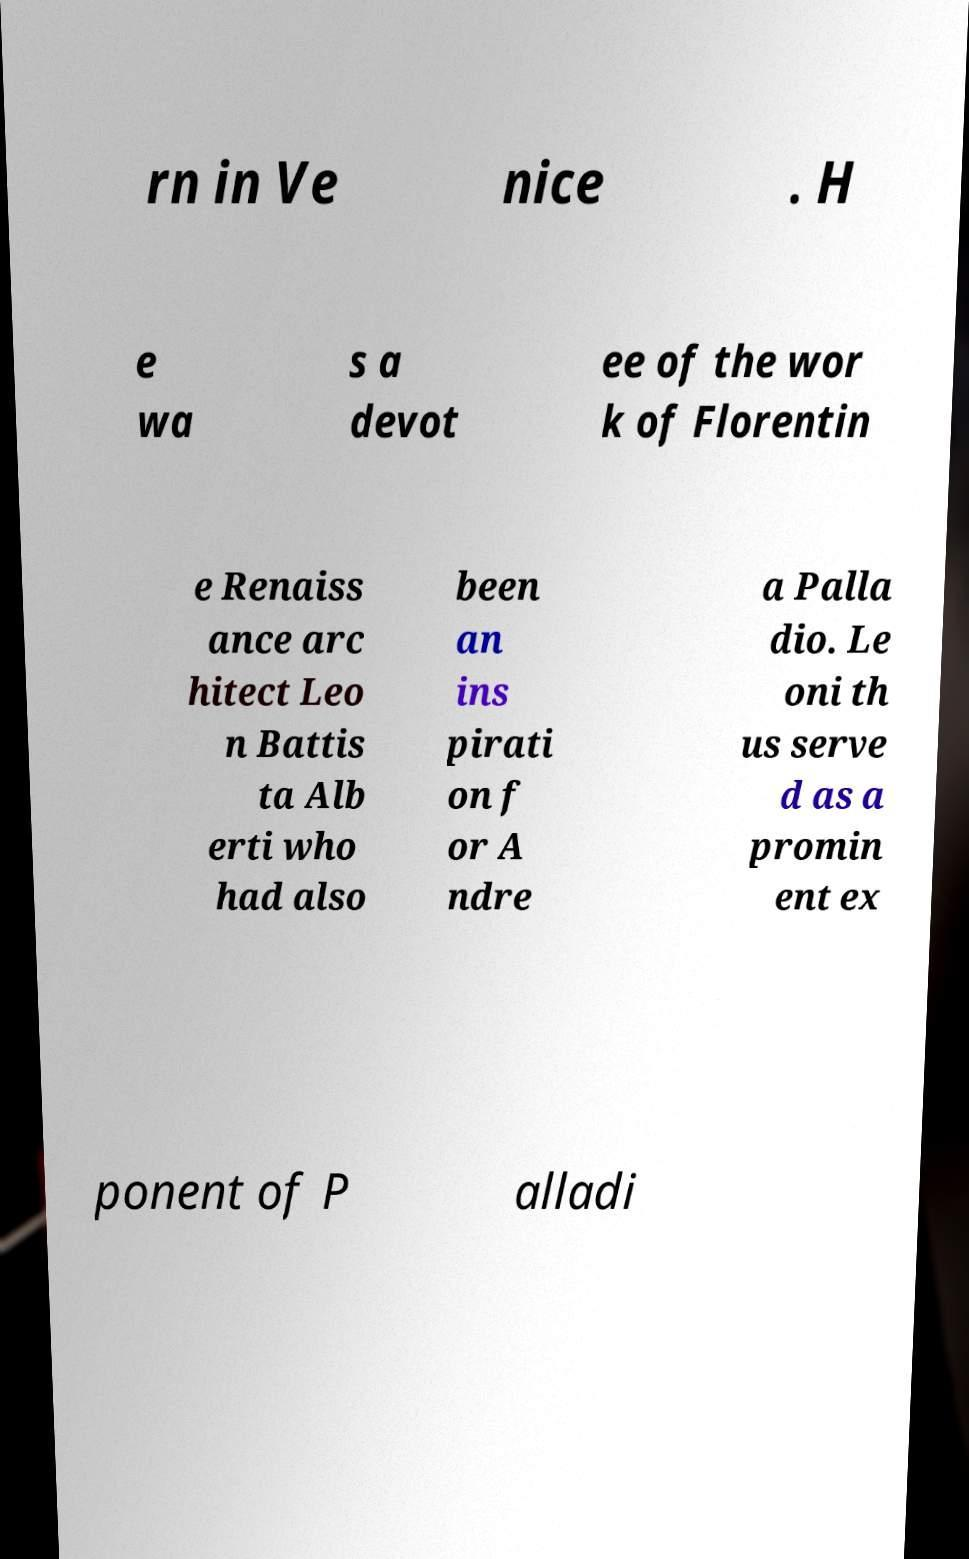There's text embedded in this image that I need extracted. Can you transcribe it verbatim? rn in Ve nice . H e wa s a devot ee of the wor k of Florentin e Renaiss ance arc hitect Leo n Battis ta Alb erti who had also been an ins pirati on f or A ndre a Palla dio. Le oni th us serve d as a promin ent ex ponent of P alladi 